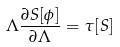Convert formula to latex. <formula><loc_0><loc_0><loc_500><loc_500>\Lambda \frac { \partial S [ \phi ] } { \partial \Lambda } = \tau [ S ]</formula> 